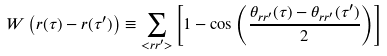Convert formula to latex. <formula><loc_0><loc_0><loc_500><loc_500>W \left ( { r } ( \tau ) - { r } ( \tau ^ { \prime } ) \right ) \equiv \sum _ { < { r } { r } ^ { \prime } > } \left [ 1 - \cos \left ( \frac { \theta _ { { r } { r } ^ { \prime } } ( \tau ) - \theta _ { { r } { r } ^ { \prime } } ( \tau ^ { \prime } ) } { 2 } \right ) \right ]</formula> 